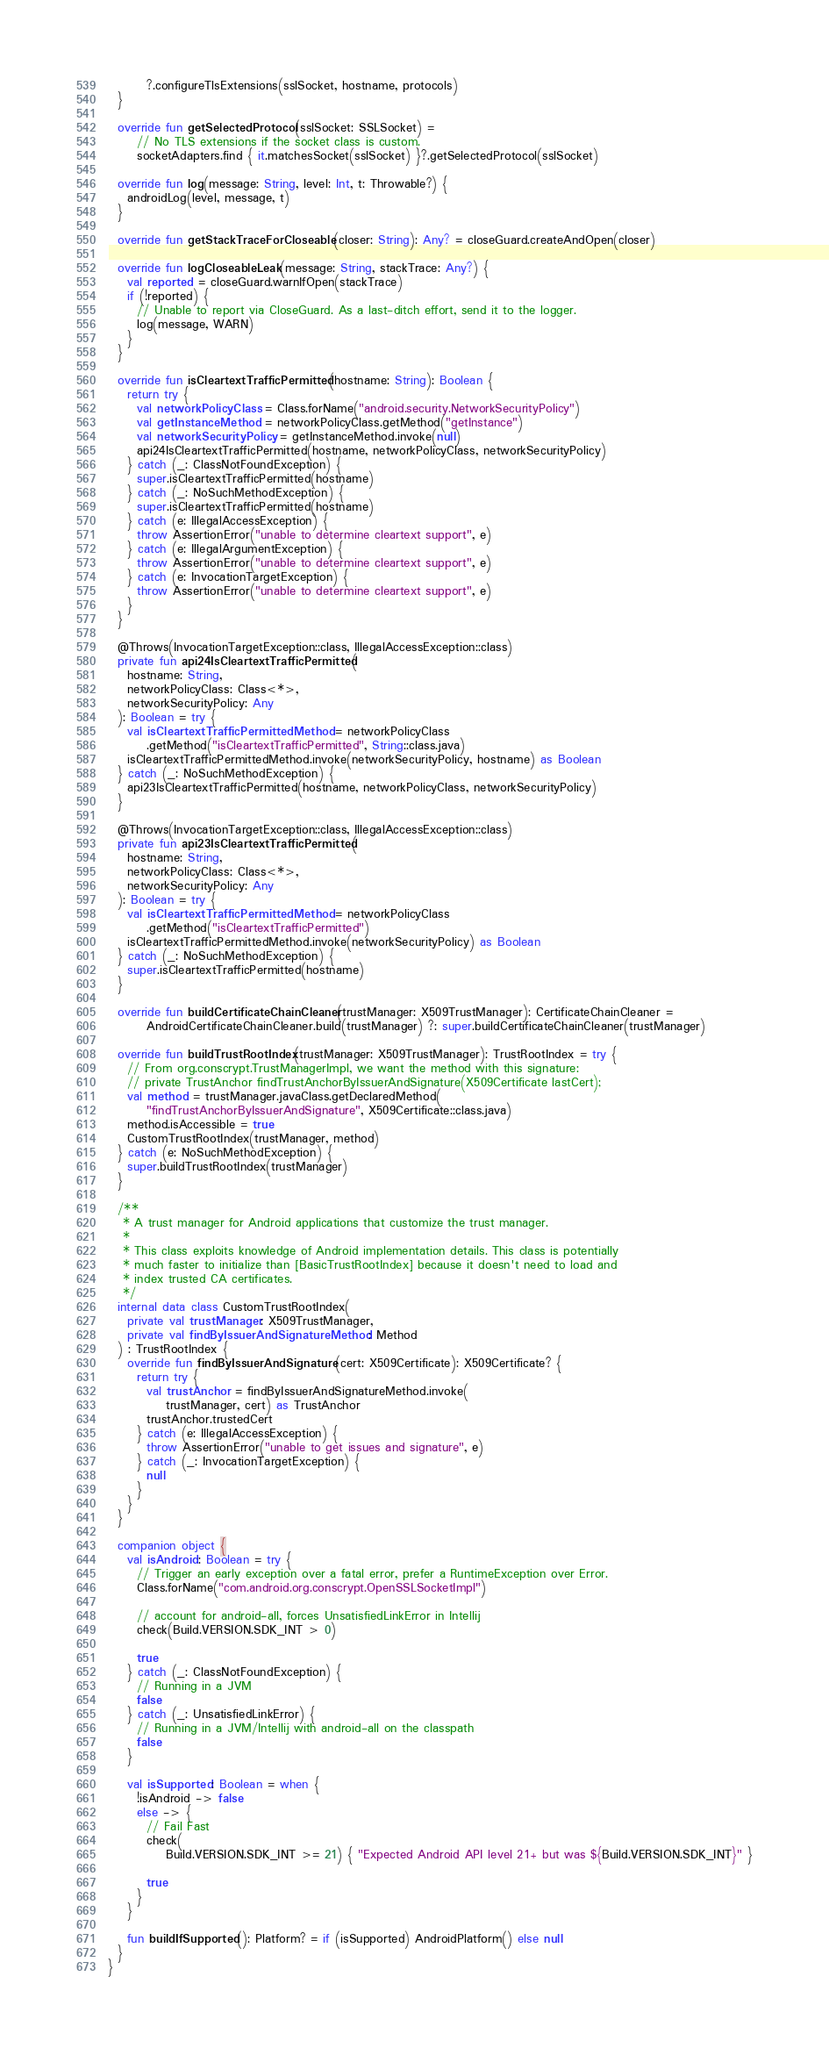<code> <loc_0><loc_0><loc_500><loc_500><_Kotlin_>        ?.configureTlsExtensions(sslSocket, hostname, protocols)
  }

  override fun getSelectedProtocol(sslSocket: SSLSocket) =
      // No TLS extensions if the socket class is custom.
      socketAdapters.find { it.matchesSocket(sslSocket) }?.getSelectedProtocol(sslSocket)

  override fun log(message: String, level: Int, t: Throwable?) {
    androidLog(level, message, t)
  }

  override fun getStackTraceForCloseable(closer: String): Any? = closeGuard.createAndOpen(closer)

  override fun logCloseableLeak(message: String, stackTrace: Any?) {
    val reported = closeGuard.warnIfOpen(stackTrace)
    if (!reported) {
      // Unable to report via CloseGuard. As a last-ditch effort, send it to the logger.
      log(message, WARN)
    }
  }

  override fun isCleartextTrafficPermitted(hostname: String): Boolean {
    return try {
      val networkPolicyClass = Class.forName("android.security.NetworkSecurityPolicy")
      val getInstanceMethod = networkPolicyClass.getMethod("getInstance")
      val networkSecurityPolicy = getInstanceMethod.invoke(null)
      api24IsCleartextTrafficPermitted(hostname, networkPolicyClass, networkSecurityPolicy)
    } catch (_: ClassNotFoundException) {
      super.isCleartextTrafficPermitted(hostname)
    } catch (_: NoSuchMethodException) {
      super.isCleartextTrafficPermitted(hostname)
    } catch (e: IllegalAccessException) {
      throw AssertionError("unable to determine cleartext support", e)
    } catch (e: IllegalArgumentException) {
      throw AssertionError("unable to determine cleartext support", e)
    } catch (e: InvocationTargetException) {
      throw AssertionError("unable to determine cleartext support", e)
    }
  }

  @Throws(InvocationTargetException::class, IllegalAccessException::class)
  private fun api24IsCleartextTrafficPermitted(
    hostname: String,
    networkPolicyClass: Class<*>,
    networkSecurityPolicy: Any
  ): Boolean = try {
    val isCleartextTrafficPermittedMethod = networkPolicyClass
        .getMethod("isCleartextTrafficPermitted", String::class.java)
    isCleartextTrafficPermittedMethod.invoke(networkSecurityPolicy, hostname) as Boolean
  } catch (_: NoSuchMethodException) {
    api23IsCleartextTrafficPermitted(hostname, networkPolicyClass, networkSecurityPolicy)
  }

  @Throws(InvocationTargetException::class, IllegalAccessException::class)
  private fun api23IsCleartextTrafficPermitted(
    hostname: String,
    networkPolicyClass: Class<*>,
    networkSecurityPolicy: Any
  ): Boolean = try {
    val isCleartextTrafficPermittedMethod = networkPolicyClass
        .getMethod("isCleartextTrafficPermitted")
    isCleartextTrafficPermittedMethod.invoke(networkSecurityPolicy) as Boolean
  } catch (_: NoSuchMethodException) {
    super.isCleartextTrafficPermitted(hostname)
  }

  override fun buildCertificateChainCleaner(trustManager: X509TrustManager): CertificateChainCleaner =
        AndroidCertificateChainCleaner.build(trustManager) ?: super.buildCertificateChainCleaner(trustManager)

  override fun buildTrustRootIndex(trustManager: X509TrustManager): TrustRootIndex = try {
    // From org.conscrypt.TrustManagerImpl, we want the method with this signature:
    // private TrustAnchor findTrustAnchorByIssuerAndSignature(X509Certificate lastCert);
    val method = trustManager.javaClass.getDeclaredMethod(
        "findTrustAnchorByIssuerAndSignature", X509Certificate::class.java)
    method.isAccessible = true
    CustomTrustRootIndex(trustManager, method)
  } catch (e: NoSuchMethodException) {
    super.buildTrustRootIndex(trustManager)
  }

  /**
   * A trust manager for Android applications that customize the trust manager.
   *
   * This class exploits knowledge of Android implementation details. This class is potentially
   * much faster to initialize than [BasicTrustRootIndex] because it doesn't need to load and
   * index trusted CA certificates.
   */
  internal data class CustomTrustRootIndex(
    private val trustManager: X509TrustManager,
    private val findByIssuerAndSignatureMethod: Method
  ) : TrustRootIndex {
    override fun findByIssuerAndSignature(cert: X509Certificate): X509Certificate? {
      return try {
        val trustAnchor = findByIssuerAndSignatureMethod.invoke(
            trustManager, cert) as TrustAnchor
        trustAnchor.trustedCert
      } catch (e: IllegalAccessException) {
        throw AssertionError("unable to get issues and signature", e)
      } catch (_: InvocationTargetException) {
        null
      }
    }
  }

  companion object {
    val isAndroid: Boolean = try {
      // Trigger an early exception over a fatal error, prefer a RuntimeException over Error.
      Class.forName("com.android.org.conscrypt.OpenSSLSocketImpl")

      // account for android-all, forces UnsatisfiedLinkError in Intellij
      check(Build.VERSION.SDK_INT > 0)

      true
    } catch (_: ClassNotFoundException) {
      // Running in a JVM
      false
    } catch (_: UnsatisfiedLinkError) {
      // Running in a JVM/Intellij with android-all on the classpath
      false
    }

    val isSupported: Boolean = when {
      !isAndroid -> false
      else -> {
        // Fail Fast
        check(
            Build.VERSION.SDK_INT >= 21) { "Expected Android API level 21+ but was ${Build.VERSION.SDK_INT}" }

        true
      }
    }

    fun buildIfSupported(): Platform? = if (isSupported) AndroidPlatform() else null
  }
}
</code> 